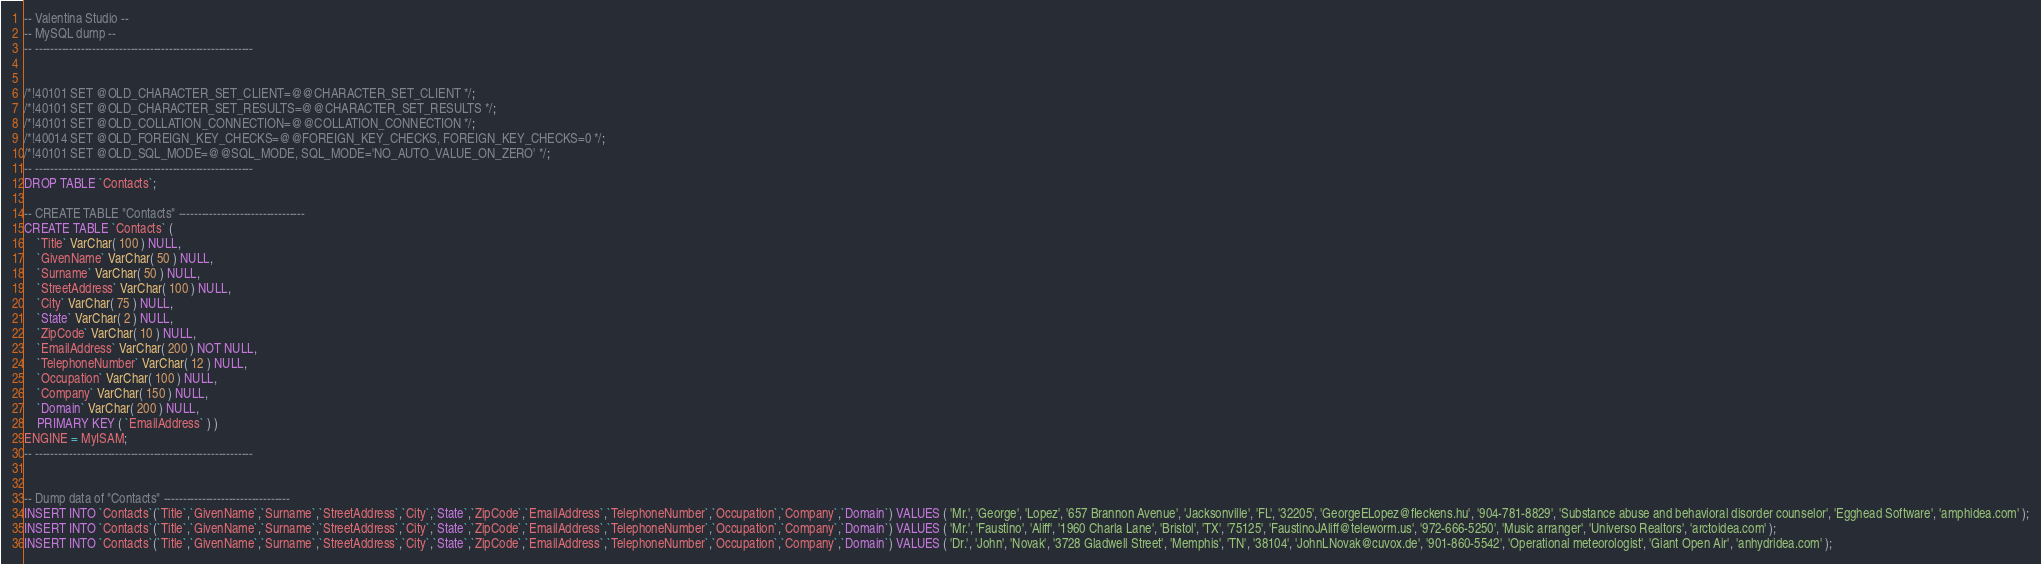Convert code to text. <code><loc_0><loc_0><loc_500><loc_500><_SQL_>-- Valentina Studio --
-- MySQL dump --
-- ---------------------------------------------------------


/*!40101 SET @OLD_CHARACTER_SET_CLIENT=@@CHARACTER_SET_CLIENT */;
/*!40101 SET @OLD_CHARACTER_SET_RESULTS=@@CHARACTER_SET_RESULTS */;
/*!40101 SET @OLD_COLLATION_CONNECTION=@@COLLATION_CONNECTION */;
/*!40014 SET @OLD_FOREIGN_KEY_CHECKS=@@FOREIGN_KEY_CHECKS, FOREIGN_KEY_CHECKS=0 */;
/*!40101 SET @OLD_SQL_MODE=@@SQL_MODE, SQL_MODE='NO_AUTO_VALUE_ON_ZERO' */;
-- ---------------------------------------------------------
DROP TABLE `Contacts`;

-- CREATE TABLE "Contacts" ---------------------------------
CREATE TABLE `Contacts` ( 
	`Title` VarChar( 100 ) NULL,
	`GivenName` VarChar( 50 ) NULL,
	`Surname` VarChar( 50 ) NULL,
	`StreetAddress` VarChar( 100 ) NULL,
	`City` VarChar( 75 ) NULL,
	`State` VarChar( 2 ) NULL,
	`ZipCode` VarChar( 10 ) NULL,
	`EmailAddress` VarChar( 200 ) NOT NULL,
	`TelephoneNumber` VarChar( 12 ) NULL,
	`Occupation` VarChar( 100 ) NULL,
	`Company` VarChar( 150 ) NULL,
	`Domain` VarChar( 200 ) NULL,
	PRIMARY KEY ( `EmailAddress` ) )
ENGINE = MyISAM;
-- ---------------------------------------------------------


-- Dump data of "Contacts" ---------------------------------
INSERT INTO `Contacts`(`Title`,`GivenName`,`Surname`,`StreetAddress`,`City`,`State`,`ZipCode`,`EmailAddress`,`TelephoneNumber`,`Occupation`,`Company`,`Domain`) VALUES ( 'Mr.', 'George', 'Lopez', '657 Brannon Avenue', 'Jacksonville', 'FL', '32205', 'GeorgeELopez@fleckens.hu', '904-781-8829', 'Substance abuse and behavioral disorder counselor', 'Egghead Software', 'amphidea.com' );
INSERT INTO `Contacts`(`Title`,`GivenName`,`Surname`,`StreetAddress`,`City`,`State`,`ZipCode`,`EmailAddress`,`TelephoneNumber`,`Occupation`,`Company`,`Domain`) VALUES ( 'Mr.', 'Faustino', 'Aliff', '1960 Charla Lane', 'Bristol', 'TX', '75125', 'FaustinoJAliff@teleworm.us', '972-666-5250', 'Music arranger', 'Universo Realtors', 'arctoidea.com' );
INSERT INTO `Contacts`(`Title`,`GivenName`,`Surname`,`StreetAddress`,`City`,`State`,`ZipCode`,`EmailAddress`,`TelephoneNumber`,`Occupation`,`Company`,`Domain`) VALUES ( 'Dr.', 'John', 'Novak', '3728 Gladwell Street', 'Memphis', 'TN', '38104', 'JohnLNovak@cuvox.de', '901-860-5542', 'Operational meteorologist', 'Giant Open Air', 'anhydridea.com' );</code> 